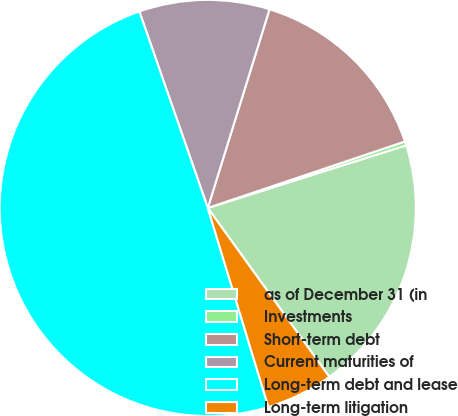Convert chart. <chart><loc_0><loc_0><loc_500><loc_500><pie_chart><fcel>as of December 31 (in<fcel>Investments<fcel>Short-term debt<fcel>Current maturities of<fcel>Long-term debt and lease<fcel>Long-term litigation<nl><fcel>19.94%<fcel>0.31%<fcel>15.03%<fcel>10.13%<fcel>49.37%<fcel>5.22%<nl></chart> 